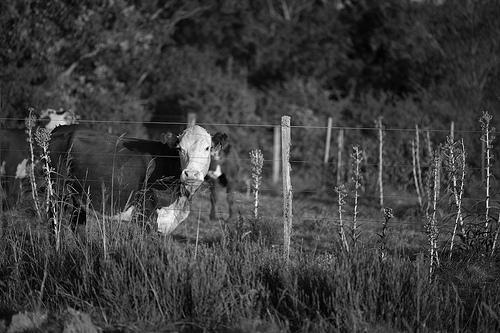How many cows are there?
Give a very brief answer. 1. 